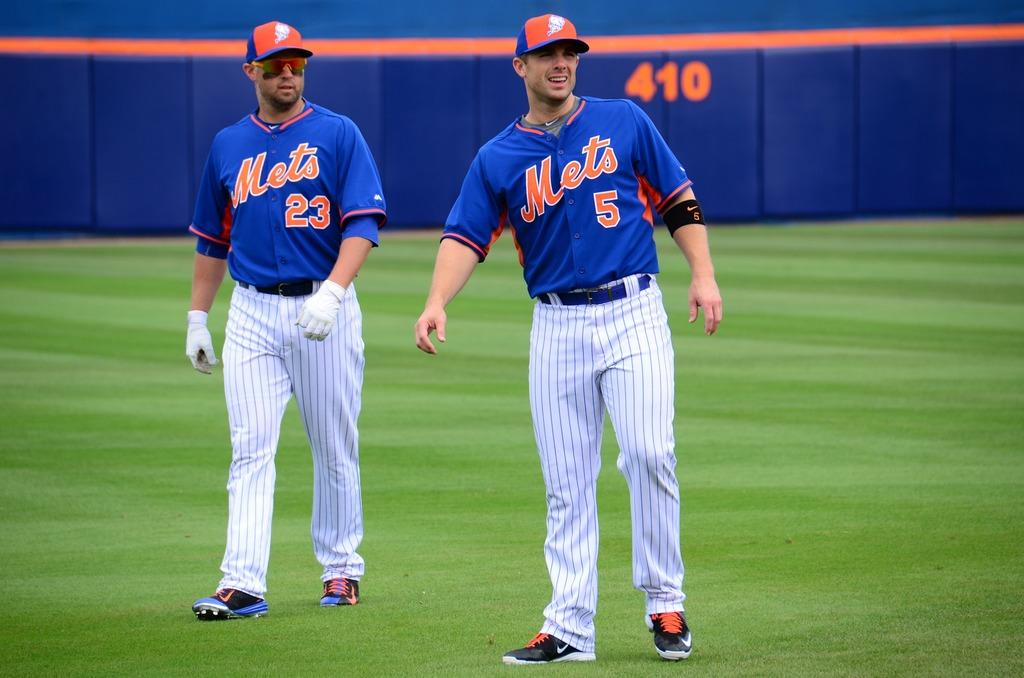<image>
Offer a succinct explanation of the picture presented. Two Mets basbeball players stand on a baseball field looking into the distance. 